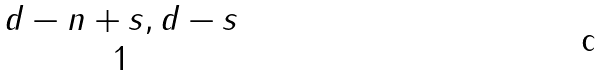<formula> <loc_0><loc_0><loc_500><loc_500>\begin{matrix} { d - n + s , d - s } \\ { 1 } \end{matrix}</formula> 